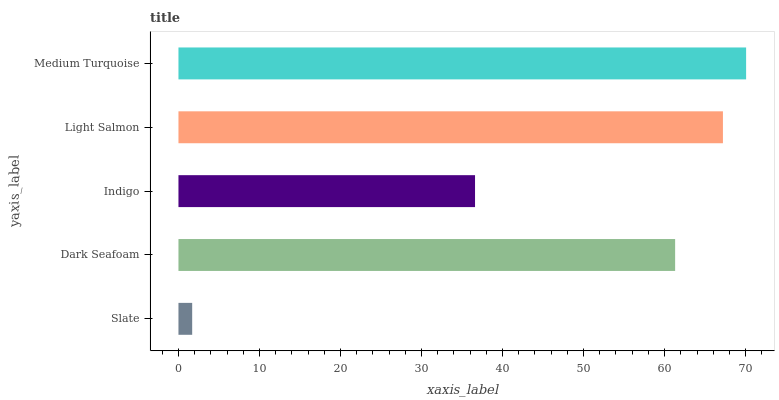Is Slate the minimum?
Answer yes or no. Yes. Is Medium Turquoise the maximum?
Answer yes or no. Yes. Is Dark Seafoam the minimum?
Answer yes or no. No. Is Dark Seafoam the maximum?
Answer yes or no. No. Is Dark Seafoam greater than Slate?
Answer yes or no. Yes. Is Slate less than Dark Seafoam?
Answer yes or no. Yes. Is Slate greater than Dark Seafoam?
Answer yes or no. No. Is Dark Seafoam less than Slate?
Answer yes or no. No. Is Dark Seafoam the high median?
Answer yes or no. Yes. Is Dark Seafoam the low median?
Answer yes or no. Yes. Is Indigo the high median?
Answer yes or no. No. Is Slate the low median?
Answer yes or no. No. 